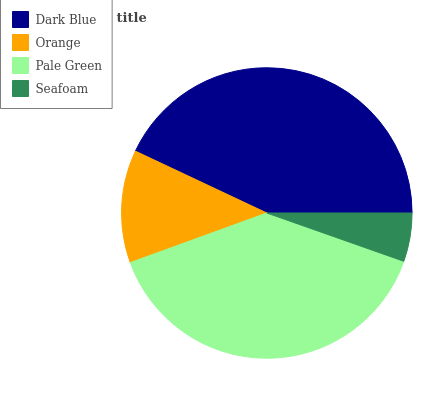Is Seafoam the minimum?
Answer yes or no. Yes. Is Dark Blue the maximum?
Answer yes or no. Yes. Is Orange the minimum?
Answer yes or no. No. Is Orange the maximum?
Answer yes or no. No. Is Dark Blue greater than Orange?
Answer yes or no. Yes. Is Orange less than Dark Blue?
Answer yes or no. Yes. Is Orange greater than Dark Blue?
Answer yes or no. No. Is Dark Blue less than Orange?
Answer yes or no. No. Is Pale Green the high median?
Answer yes or no. Yes. Is Orange the low median?
Answer yes or no. Yes. Is Orange the high median?
Answer yes or no. No. Is Pale Green the low median?
Answer yes or no. No. 